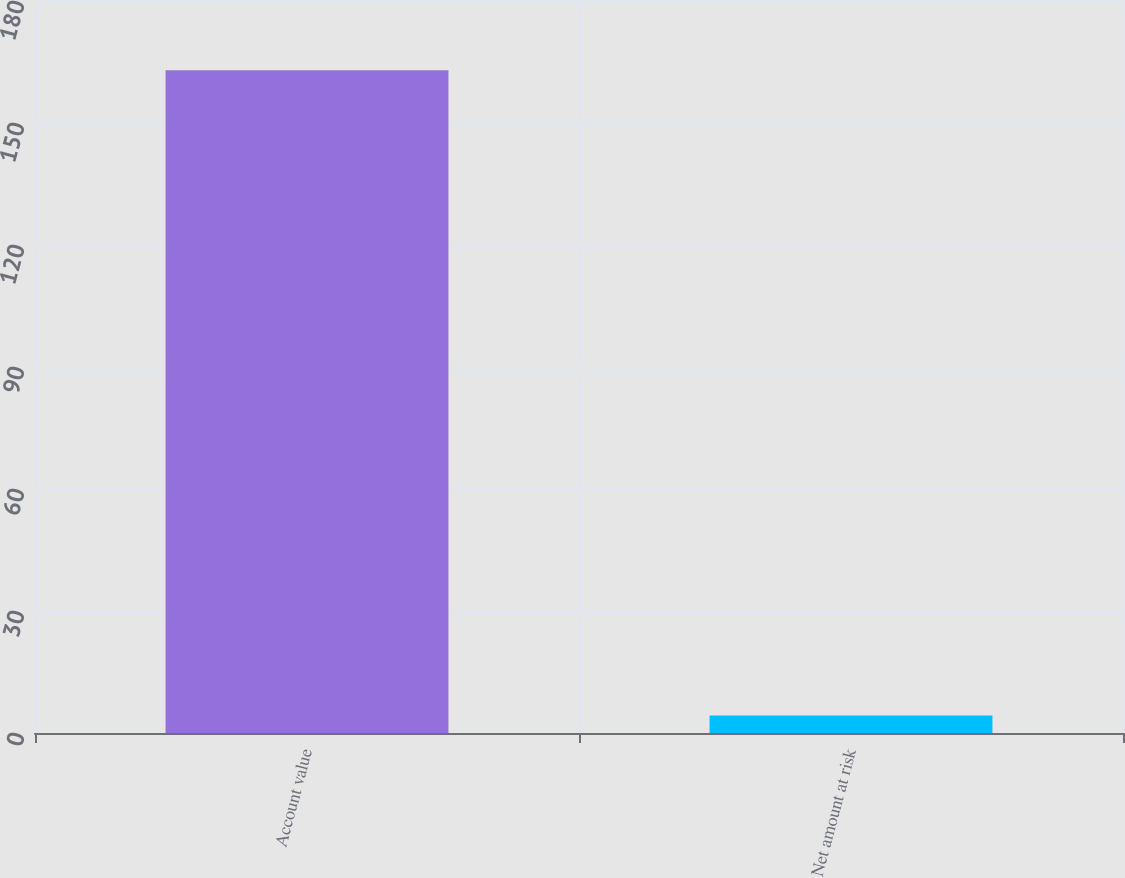<chart> <loc_0><loc_0><loc_500><loc_500><bar_chart><fcel>Account value<fcel>Net amount at risk<nl><fcel>163<fcel>4.31<nl></chart> 